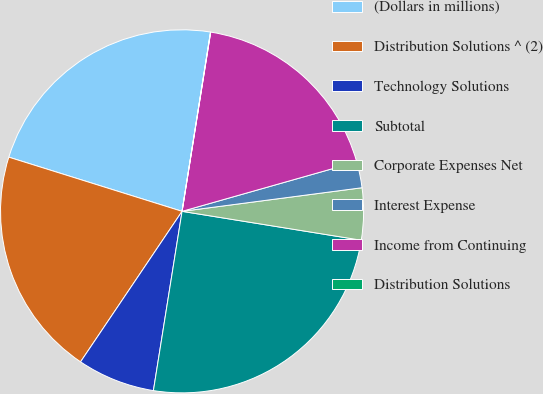<chart> <loc_0><loc_0><loc_500><loc_500><pie_chart><fcel>(Dollars in millions)<fcel>Distribution Solutions ^ (2)<fcel>Technology Solutions<fcel>Subtotal<fcel>Corporate Expenses Net<fcel>Interest Expense<fcel>Income from Continuing<fcel>Distribution Solutions<nl><fcel>22.68%<fcel>20.38%<fcel>6.92%<fcel>24.98%<fcel>4.62%<fcel>2.32%<fcel>18.08%<fcel>0.02%<nl></chart> 